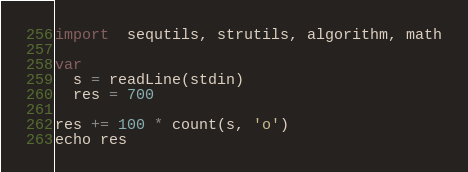<code> <loc_0><loc_0><loc_500><loc_500><_Nim_>import  sequtils, strutils, algorithm, math

var
  s = readLine(stdin)
  res = 700

res += 100 * count(s, 'o')
echo res</code> 